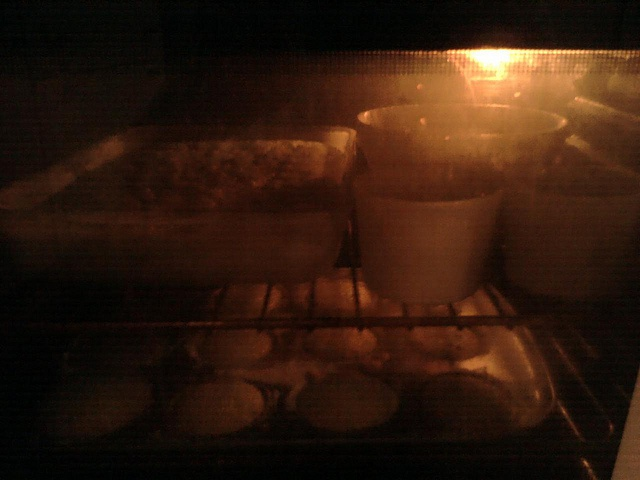Describe the objects in this image and their specific colors. I can see oven in black, maroon, brown, and orange tones, cake in black, maroon, and brown tones, cup in black and maroon tones, bowl in black, maroon, and brown tones, and bowl in black, brown, maroon, and orange tones in this image. 